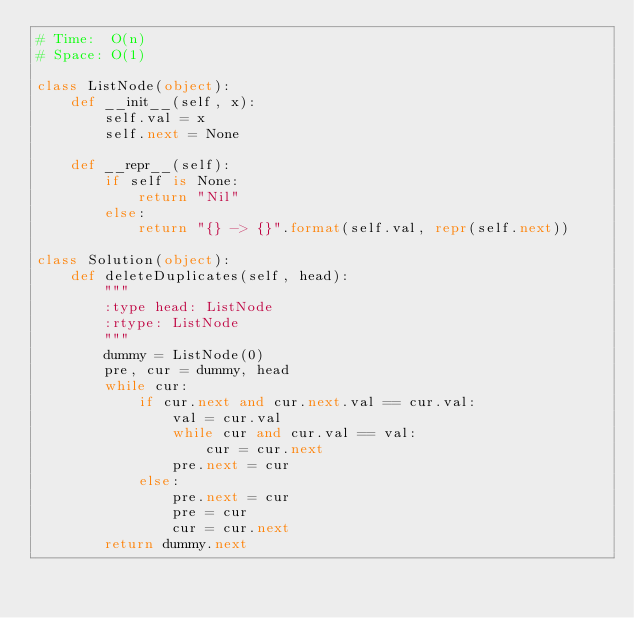Convert code to text. <code><loc_0><loc_0><loc_500><loc_500><_Python_># Time:  O(n)
# Space: O(1)

class ListNode(object):
    def __init__(self, x):
        self.val = x
        self.next = None

    def __repr__(self):
        if self is None:
            return "Nil"
        else:
            return "{} -> {}".format(self.val, repr(self.next))

class Solution(object):
    def deleteDuplicates(self, head):
        """
        :type head: ListNode
        :rtype: ListNode
        """
        dummy = ListNode(0)
        pre, cur = dummy, head
        while cur:
            if cur.next and cur.next.val == cur.val:
                val = cur.val
                while cur and cur.val == val:
                    cur = cur.next
                pre.next = cur
            else:
                pre.next = cur
                pre = cur
                cur = cur.next
        return dummy.next

</code> 